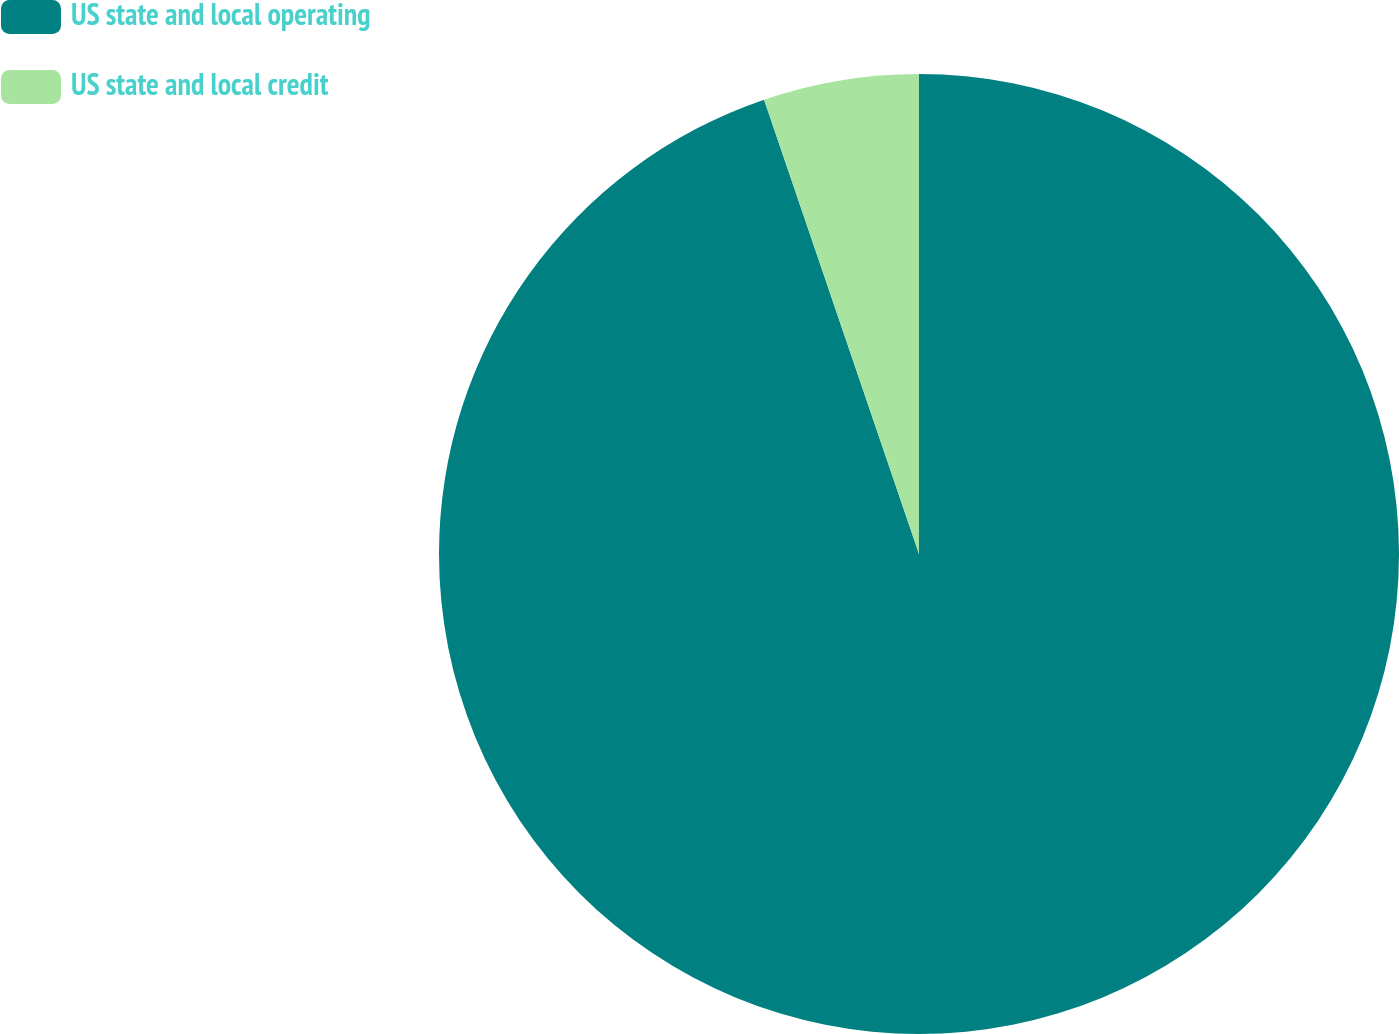<chart> <loc_0><loc_0><loc_500><loc_500><pie_chart><fcel>US state and local operating<fcel>US state and local credit<nl><fcel>94.77%<fcel>5.23%<nl></chart> 